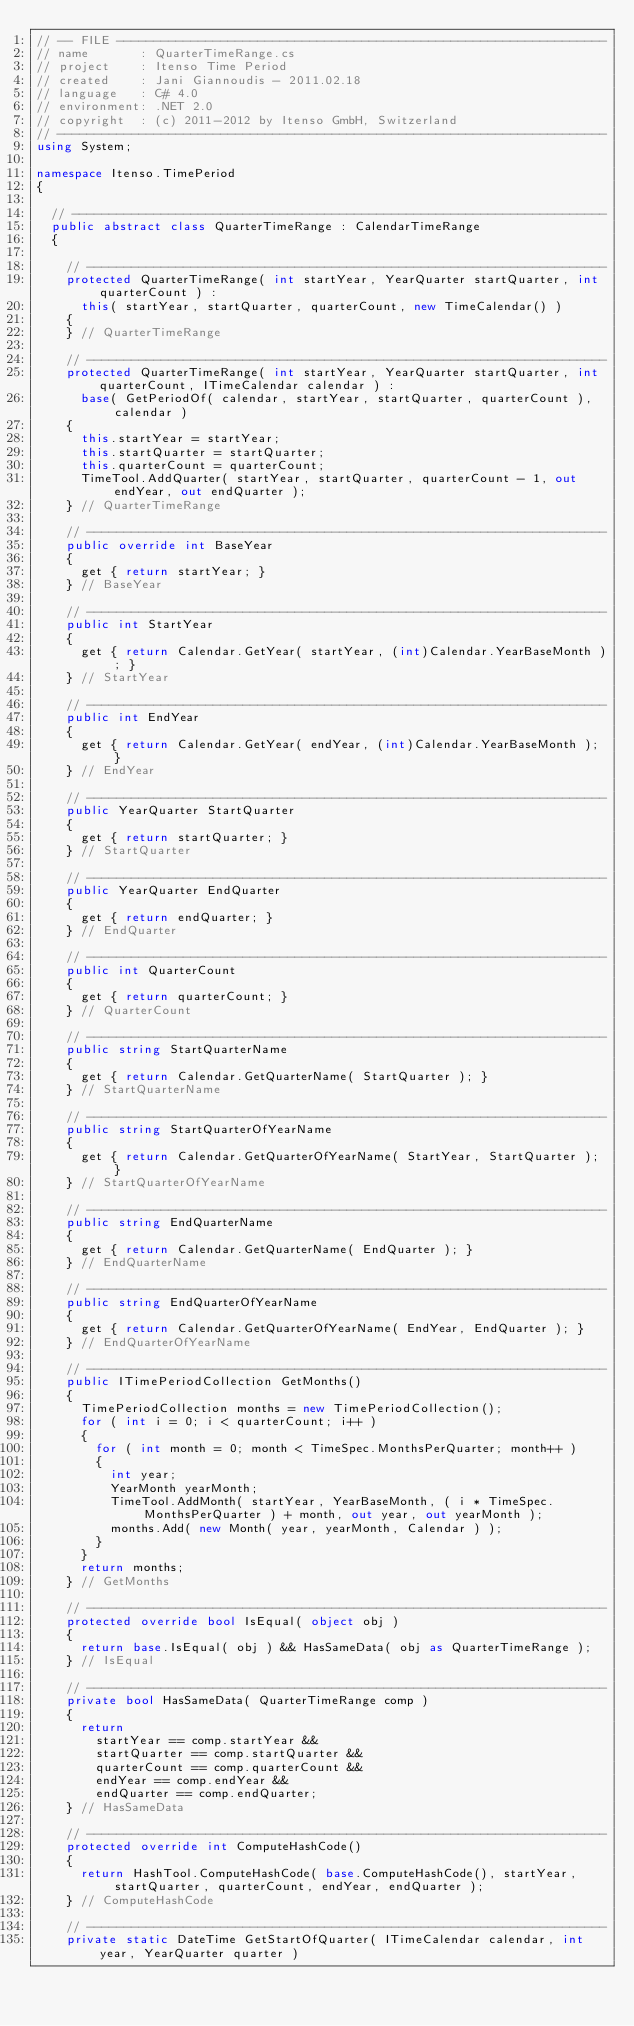Convert code to text. <code><loc_0><loc_0><loc_500><loc_500><_C#_>// -- FILE ------------------------------------------------------------------
// name       : QuarterTimeRange.cs
// project    : Itenso Time Period
// created    : Jani Giannoudis - 2011.02.18
// language   : C# 4.0
// environment: .NET 2.0
// copyright  : (c) 2011-2012 by Itenso GmbH, Switzerland
// --------------------------------------------------------------------------
using System;

namespace Itenso.TimePeriod
{

	// ------------------------------------------------------------------------
	public abstract class QuarterTimeRange : CalendarTimeRange
	{

		// ----------------------------------------------------------------------
		protected QuarterTimeRange( int startYear, YearQuarter startQuarter, int quarterCount ) :
			this( startYear, startQuarter, quarterCount, new TimeCalendar() )
		{
		} // QuarterTimeRange

		// ----------------------------------------------------------------------
		protected QuarterTimeRange( int startYear, YearQuarter startQuarter, int quarterCount, ITimeCalendar calendar ) :
			base( GetPeriodOf( calendar, startYear, startQuarter, quarterCount ), calendar )
		{
			this.startYear = startYear;
			this.startQuarter = startQuarter;
			this.quarterCount = quarterCount;
			TimeTool.AddQuarter( startYear, startQuarter, quarterCount - 1, out endYear, out endQuarter );
		} // QuarterTimeRange

		// ----------------------------------------------------------------------
		public override int BaseYear
		{
			get { return startYear; }
		} // BaseYear

		// ----------------------------------------------------------------------
		public int StartYear
		{
			get { return Calendar.GetYear( startYear, (int)Calendar.YearBaseMonth ); }
		} // StartYear

		// ----------------------------------------------------------------------
		public int EndYear
		{
			get { return Calendar.GetYear( endYear, (int)Calendar.YearBaseMonth ); }
		} // EndYear

		// ----------------------------------------------------------------------
		public YearQuarter StartQuarter
		{
			get { return startQuarter; }
		} // StartQuarter

		// ----------------------------------------------------------------------
		public YearQuarter EndQuarter
		{
			get { return endQuarter; }
		} // EndQuarter

		// ----------------------------------------------------------------------
		public int QuarterCount
		{
			get { return quarterCount; }
		} // QuarterCount

		// ----------------------------------------------------------------------
		public string StartQuarterName
		{
			get { return Calendar.GetQuarterName( StartQuarter ); }
		} // StartQuarterName

		// ----------------------------------------------------------------------
		public string StartQuarterOfYearName
		{
			get { return Calendar.GetQuarterOfYearName( StartYear, StartQuarter ); }
		} // StartQuarterOfYearName

		// ----------------------------------------------------------------------
		public string EndQuarterName
		{
			get { return Calendar.GetQuarterName( EndQuarter ); }
		} // EndQuarterName

		// ----------------------------------------------------------------------
		public string EndQuarterOfYearName
		{
			get { return Calendar.GetQuarterOfYearName( EndYear, EndQuarter ); }
		} // EndQuarterOfYearName

		// ----------------------------------------------------------------------
		public ITimePeriodCollection GetMonths()
		{
			TimePeriodCollection months = new TimePeriodCollection();
			for ( int i = 0; i < quarterCount; i++ )
			{
				for ( int month = 0; month < TimeSpec.MonthsPerQuarter; month++ )
				{
					int year;
					YearMonth yearMonth;
					TimeTool.AddMonth( startYear, YearBaseMonth, ( i * TimeSpec.MonthsPerQuarter ) + month, out year, out yearMonth );
					months.Add( new Month( year, yearMonth, Calendar ) );
				}
			}
			return months;
		} // GetMonths

		// ----------------------------------------------------------------------
		protected override bool IsEqual( object obj )
		{
			return base.IsEqual( obj ) && HasSameData( obj as QuarterTimeRange );
		} // IsEqual

		// ----------------------------------------------------------------------
		private bool HasSameData( QuarterTimeRange comp )
		{
			return
				startYear == comp.startYear &&
				startQuarter == comp.startQuarter &&
				quarterCount == comp.quarterCount &&
				endYear == comp.endYear &&
				endQuarter == comp.endQuarter;
		} // HasSameData

		// ----------------------------------------------------------------------
		protected override int ComputeHashCode()
		{
			return HashTool.ComputeHashCode( base.ComputeHashCode(), startYear, startQuarter, quarterCount, endYear, endQuarter );
		} // ComputeHashCode

		// ----------------------------------------------------------------------
		private static DateTime GetStartOfQuarter( ITimeCalendar calendar, int year, YearQuarter quarter )</code> 